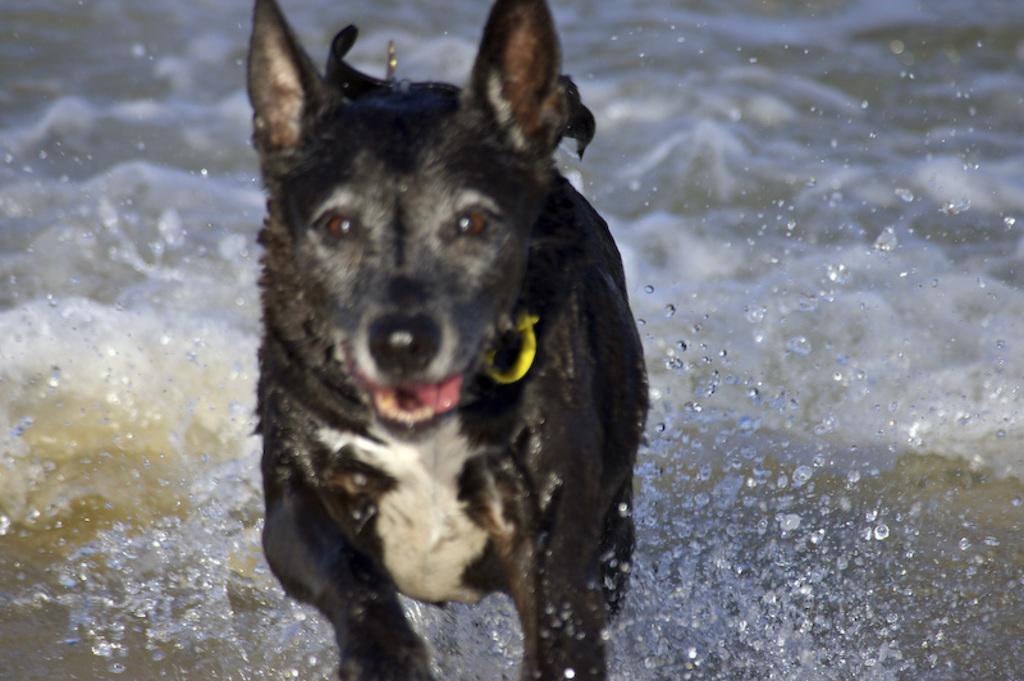Please provide a concise description of this image. In this picture, we can see a dog, and we can see water. 